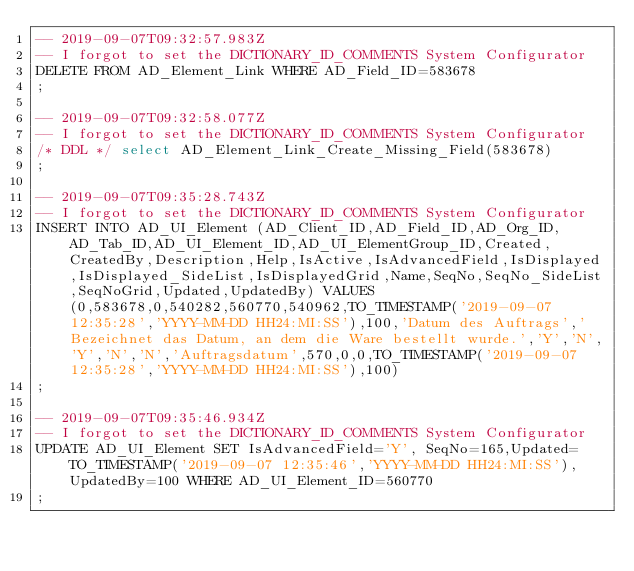<code> <loc_0><loc_0><loc_500><loc_500><_SQL_>-- 2019-09-07T09:32:57.983Z
-- I forgot to set the DICTIONARY_ID_COMMENTS System Configurator
DELETE FROM AD_Element_Link WHERE AD_Field_ID=583678
;

-- 2019-09-07T09:32:58.077Z
-- I forgot to set the DICTIONARY_ID_COMMENTS System Configurator
/* DDL */ select AD_Element_Link_Create_Missing_Field(583678)
;

-- 2019-09-07T09:35:28.743Z
-- I forgot to set the DICTIONARY_ID_COMMENTS System Configurator
INSERT INTO AD_UI_Element (AD_Client_ID,AD_Field_ID,AD_Org_ID,AD_Tab_ID,AD_UI_Element_ID,AD_UI_ElementGroup_ID,Created,CreatedBy,Description,Help,IsActive,IsAdvancedField,IsDisplayed,IsDisplayed_SideList,IsDisplayedGrid,Name,SeqNo,SeqNo_SideList,SeqNoGrid,Updated,UpdatedBy) VALUES (0,583678,0,540282,560770,540962,TO_TIMESTAMP('2019-09-07 12:35:28','YYYY-MM-DD HH24:MI:SS'),100,'Datum des Auftrags','Bezeichnet das Datum, an dem die Ware bestellt wurde.','Y','N','Y','N','N','Auftragsdatum',570,0,0,TO_TIMESTAMP('2019-09-07 12:35:28','YYYY-MM-DD HH24:MI:SS'),100)
;

-- 2019-09-07T09:35:46.934Z
-- I forgot to set the DICTIONARY_ID_COMMENTS System Configurator
UPDATE AD_UI_Element SET IsAdvancedField='Y', SeqNo=165,Updated=TO_TIMESTAMP('2019-09-07 12:35:46','YYYY-MM-DD HH24:MI:SS'),UpdatedBy=100 WHERE AD_UI_Element_ID=560770
;

</code> 